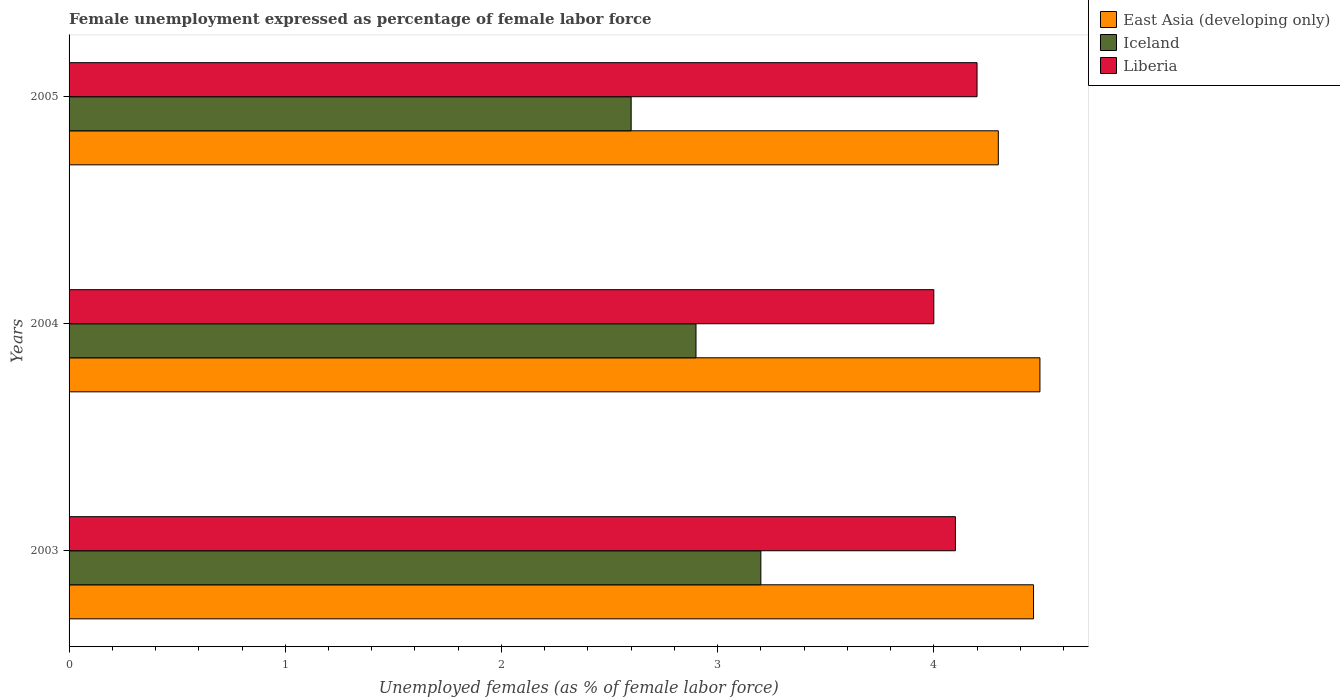Are the number of bars on each tick of the Y-axis equal?
Your answer should be compact. Yes. How many bars are there on the 3rd tick from the bottom?
Your response must be concise. 3. What is the label of the 3rd group of bars from the top?
Keep it short and to the point. 2003. In how many cases, is the number of bars for a given year not equal to the number of legend labels?
Provide a succinct answer. 0. What is the unemployment in females in in East Asia (developing only) in 2004?
Your response must be concise. 4.49. Across all years, what is the maximum unemployment in females in in East Asia (developing only)?
Your response must be concise. 4.49. Across all years, what is the minimum unemployment in females in in Iceland?
Offer a very short reply. 2.6. In which year was the unemployment in females in in Iceland maximum?
Ensure brevity in your answer.  2003. What is the total unemployment in females in in Liberia in the graph?
Your answer should be compact. 12.3. What is the difference between the unemployment in females in in Liberia in 2003 and that in 2005?
Provide a succinct answer. -0.1. What is the difference between the unemployment in females in in Liberia in 2005 and the unemployment in females in in East Asia (developing only) in 2003?
Make the answer very short. -0.26. What is the average unemployment in females in in Liberia per year?
Offer a terse response. 4.1. In the year 2005, what is the difference between the unemployment in females in in Iceland and unemployment in females in in Liberia?
Keep it short and to the point. -1.6. What is the ratio of the unemployment in females in in Liberia in 2003 to that in 2005?
Offer a terse response. 0.98. What is the difference between the highest and the second highest unemployment in females in in Iceland?
Your answer should be very brief. 0.3. What is the difference between the highest and the lowest unemployment in females in in Liberia?
Provide a succinct answer. 0.2. Is the sum of the unemployment in females in in Liberia in 2003 and 2004 greater than the maximum unemployment in females in in Iceland across all years?
Offer a very short reply. Yes. What does the 3rd bar from the top in 2004 represents?
Your answer should be very brief. East Asia (developing only). What does the 3rd bar from the bottom in 2004 represents?
Ensure brevity in your answer.  Liberia. How many bars are there?
Provide a short and direct response. 9. What is the difference between two consecutive major ticks on the X-axis?
Offer a terse response. 1. Are the values on the major ticks of X-axis written in scientific E-notation?
Your answer should be very brief. No. Does the graph contain any zero values?
Provide a succinct answer. No. Does the graph contain grids?
Provide a succinct answer. No. Where does the legend appear in the graph?
Your answer should be compact. Top right. How are the legend labels stacked?
Provide a short and direct response. Vertical. What is the title of the graph?
Ensure brevity in your answer.  Female unemployment expressed as percentage of female labor force. Does "Uganda" appear as one of the legend labels in the graph?
Offer a terse response. No. What is the label or title of the X-axis?
Provide a succinct answer. Unemployed females (as % of female labor force). What is the Unemployed females (as % of female labor force) of East Asia (developing only) in 2003?
Your answer should be very brief. 4.46. What is the Unemployed females (as % of female labor force) of Iceland in 2003?
Provide a short and direct response. 3.2. What is the Unemployed females (as % of female labor force) in Liberia in 2003?
Provide a short and direct response. 4.1. What is the Unemployed females (as % of female labor force) of East Asia (developing only) in 2004?
Offer a very short reply. 4.49. What is the Unemployed females (as % of female labor force) of Iceland in 2004?
Offer a terse response. 2.9. What is the Unemployed females (as % of female labor force) of Liberia in 2004?
Your answer should be compact. 4. What is the Unemployed females (as % of female labor force) of East Asia (developing only) in 2005?
Provide a short and direct response. 4.3. What is the Unemployed females (as % of female labor force) of Iceland in 2005?
Provide a succinct answer. 2.6. What is the Unemployed females (as % of female labor force) in Liberia in 2005?
Provide a short and direct response. 4.2. Across all years, what is the maximum Unemployed females (as % of female labor force) in East Asia (developing only)?
Provide a short and direct response. 4.49. Across all years, what is the maximum Unemployed females (as % of female labor force) in Iceland?
Provide a succinct answer. 3.2. Across all years, what is the maximum Unemployed females (as % of female labor force) of Liberia?
Keep it short and to the point. 4.2. Across all years, what is the minimum Unemployed females (as % of female labor force) in East Asia (developing only)?
Keep it short and to the point. 4.3. Across all years, what is the minimum Unemployed females (as % of female labor force) in Iceland?
Offer a very short reply. 2.6. What is the total Unemployed females (as % of female labor force) in East Asia (developing only) in the graph?
Provide a short and direct response. 13.25. What is the total Unemployed females (as % of female labor force) of Liberia in the graph?
Your response must be concise. 12.3. What is the difference between the Unemployed females (as % of female labor force) of East Asia (developing only) in 2003 and that in 2004?
Your answer should be very brief. -0.03. What is the difference between the Unemployed females (as % of female labor force) of Liberia in 2003 and that in 2004?
Make the answer very short. 0.1. What is the difference between the Unemployed females (as % of female labor force) of East Asia (developing only) in 2003 and that in 2005?
Your answer should be compact. 0.16. What is the difference between the Unemployed females (as % of female labor force) in East Asia (developing only) in 2004 and that in 2005?
Make the answer very short. 0.19. What is the difference between the Unemployed females (as % of female labor force) in Liberia in 2004 and that in 2005?
Ensure brevity in your answer.  -0.2. What is the difference between the Unemployed females (as % of female labor force) in East Asia (developing only) in 2003 and the Unemployed females (as % of female labor force) in Iceland in 2004?
Your response must be concise. 1.56. What is the difference between the Unemployed females (as % of female labor force) of East Asia (developing only) in 2003 and the Unemployed females (as % of female labor force) of Liberia in 2004?
Provide a short and direct response. 0.46. What is the difference between the Unemployed females (as % of female labor force) in Iceland in 2003 and the Unemployed females (as % of female labor force) in Liberia in 2004?
Your answer should be very brief. -0.8. What is the difference between the Unemployed females (as % of female labor force) of East Asia (developing only) in 2003 and the Unemployed females (as % of female labor force) of Iceland in 2005?
Give a very brief answer. 1.86. What is the difference between the Unemployed females (as % of female labor force) in East Asia (developing only) in 2003 and the Unemployed females (as % of female labor force) in Liberia in 2005?
Keep it short and to the point. 0.26. What is the difference between the Unemployed females (as % of female labor force) in East Asia (developing only) in 2004 and the Unemployed females (as % of female labor force) in Iceland in 2005?
Make the answer very short. 1.89. What is the difference between the Unemployed females (as % of female labor force) in East Asia (developing only) in 2004 and the Unemployed females (as % of female labor force) in Liberia in 2005?
Provide a short and direct response. 0.29. What is the difference between the Unemployed females (as % of female labor force) in Iceland in 2004 and the Unemployed females (as % of female labor force) in Liberia in 2005?
Your response must be concise. -1.3. What is the average Unemployed females (as % of female labor force) in East Asia (developing only) per year?
Offer a very short reply. 4.42. What is the average Unemployed females (as % of female labor force) in Liberia per year?
Give a very brief answer. 4.1. In the year 2003, what is the difference between the Unemployed females (as % of female labor force) of East Asia (developing only) and Unemployed females (as % of female labor force) of Iceland?
Make the answer very short. 1.26. In the year 2003, what is the difference between the Unemployed females (as % of female labor force) of East Asia (developing only) and Unemployed females (as % of female labor force) of Liberia?
Give a very brief answer. 0.36. In the year 2004, what is the difference between the Unemployed females (as % of female labor force) of East Asia (developing only) and Unemployed females (as % of female labor force) of Iceland?
Your answer should be compact. 1.59. In the year 2004, what is the difference between the Unemployed females (as % of female labor force) in East Asia (developing only) and Unemployed females (as % of female labor force) in Liberia?
Your answer should be very brief. 0.49. In the year 2005, what is the difference between the Unemployed females (as % of female labor force) of East Asia (developing only) and Unemployed females (as % of female labor force) of Iceland?
Provide a succinct answer. 1.7. In the year 2005, what is the difference between the Unemployed females (as % of female labor force) in East Asia (developing only) and Unemployed females (as % of female labor force) in Liberia?
Make the answer very short. 0.1. What is the ratio of the Unemployed females (as % of female labor force) in East Asia (developing only) in 2003 to that in 2004?
Make the answer very short. 0.99. What is the ratio of the Unemployed females (as % of female labor force) in Iceland in 2003 to that in 2004?
Your answer should be compact. 1.1. What is the ratio of the Unemployed females (as % of female labor force) of East Asia (developing only) in 2003 to that in 2005?
Offer a terse response. 1.04. What is the ratio of the Unemployed females (as % of female labor force) in Iceland in 2003 to that in 2005?
Keep it short and to the point. 1.23. What is the ratio of the Unemployed females (as % of female labor force) of Liberia in 2003 to that in 2005?
Make the answer very short. 0.98. What is the ratio of the Unemployed females (as % of female labor force) in East Asia (developing only) in 2004 to that in 2005?
Ensure brevity in your answer.  1.04. What is the ratio of the Unemployed females (as % of female labor force) of Iceland in 2004 to that in 2005?
Your answer should be compact. 1.12. What is the ratio of the Unemployed females (as % of female labor force) in Liberia in 2004 to that in 2005?
Your response must be concise. 0.95. What is the difference between the highest and the second highest Unemployed females (as % of female labor force) in East Asia (developing only)?
Your response must be concise. 0.03. What is the difference between the highest and the second highest Unemployed females (as % of female labor force) of Liberia?
Make the answer very short. 0.1. What is the difference between the highest and the lowest Unemployed females (as % of female labor force) of East Asia (developing only)?
Your answer should be very brief. 0.19. What is the difference between the highest and the lowest Unemployed females (as % of female labor force) of Iceland?
Offer a very short reply. 0.6. 